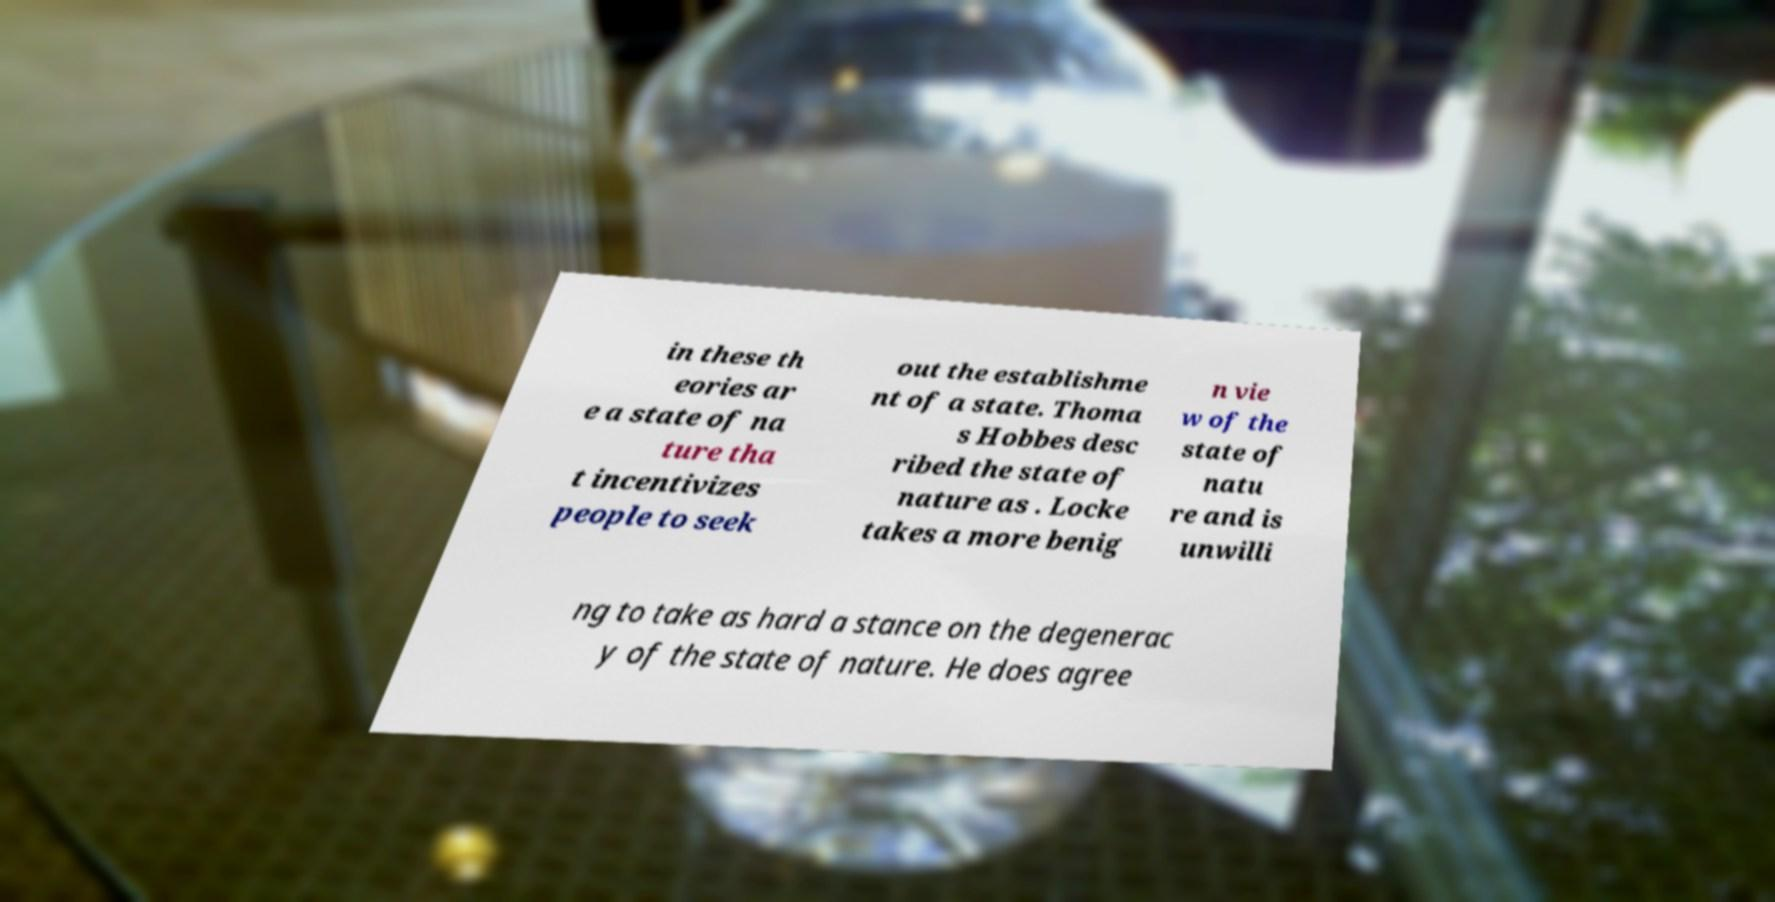There's text embedded in this image that I need extracted. Can you transcribe it verbatim? in these th eories ar e a state of na ture tha t incentivizes people to seek out the establishme nt of a state. Thoma s Hobbes desc ribed the state of nature as . Locke takes a more benig n vie w of the state of natu re and is unwilli ng to take as hard a stance on the degenerac y of the state of nature. He does agree 